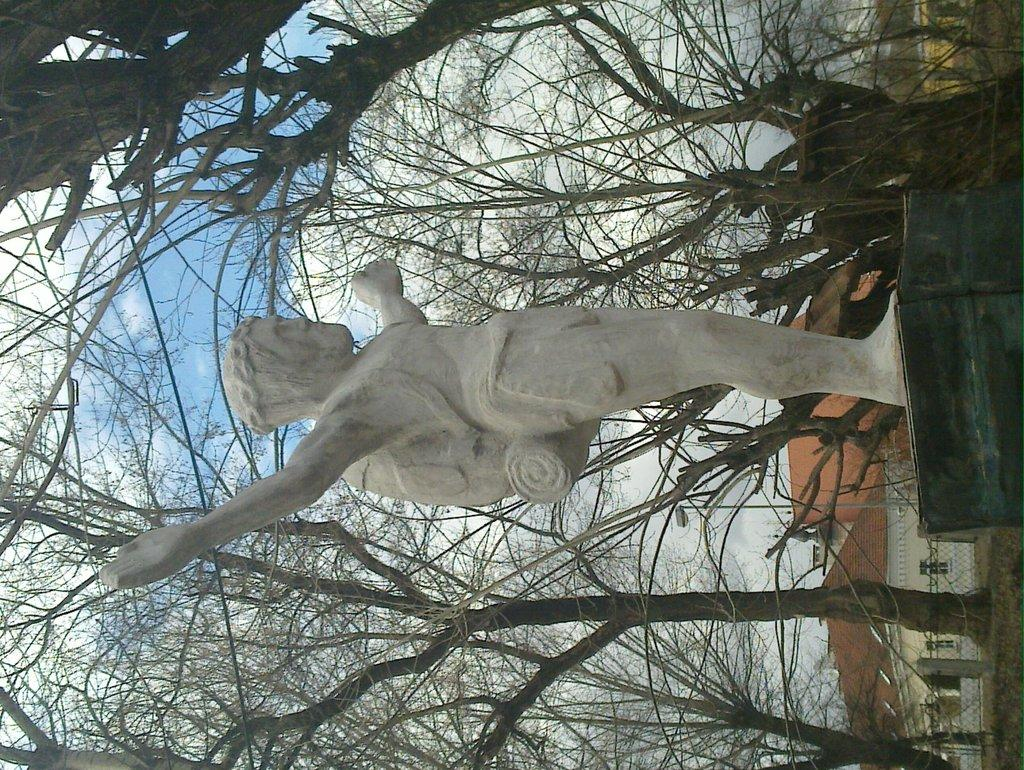What is the main subject in the image? There is a sculpture in the image. What other elements can be seen in the image? There are trees, houses, poles, a fence, windows, and light visible in the image. What is visible in the background of the image? The sky is visible in the background of the image. What type of quince is being used to create the sculpture in the image? There is no quince present in the image, as the main subject is a sculpture, not a fruit. How many fifths are visible in the image? The concept of "fifths" is not applicable to the elements present in the image, as it refers to a fraction or division that is not relevant to the visual content. 